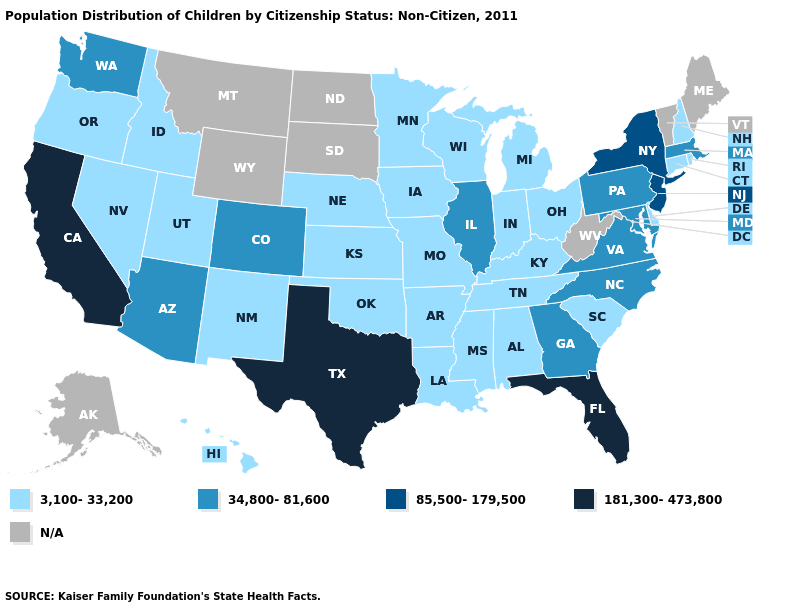Which states have the lowest value in the USA?
Answer briefly. Alabama, Arkansas, Connecticut, Delaware, Hawaii, Idaho, Indiana, Iowa, Kansas, Kentucky, Louisiana, Michigan, Minnesota, Mississippi, Missouri, Nebraska, Nevada, New Hampshire, New Mexico, Ohio, Oklahoma, Oregon, Rhode Island, South Carolina, Tennessee, Utah, Wisconsin. What is the lowest value in the West?
Short answer required. 3,100-33,200. Does Utah have the lowest value in the USA?
Write a very short answer. Yes. What is the highest value in states that border South Dakota?
Give a very brief answer. 3,100-33,200. Which states have the highest value in the USA?
Keep it brief. California, Florida, Texas. What is the value of Nebraska?
Be succinct. 3,100-33,200. Name the states that have a value in the range 34,800-81,600?
Be succinct. Arizona, Colorado, Georgia, Illinois, Maryland, Massachusetts, North Carolina, Pennsylvania, Virginia, Washington. Among the states that border Maryland , does Delaware have the lowest value?
Short answer required. Yes. What is the value of South Dakota?
Short answer required. N/A. Which states hav the highest value in the West?
Concise answer only. California. What is the value of Connecticut?
Concise answer only. 3,100-33,200. Name the states that have a value in the range 34,800-81,600?
Answer briefly. Arizona, Colorado, Georgia, Illinois, Maryland, Massachusetts, North Carolina, Pennsylvania, Virginia, Washington. 